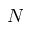Convert formula to latex. <formula><loc_0><loc_0><loc_500><loc_500>N</formula> 